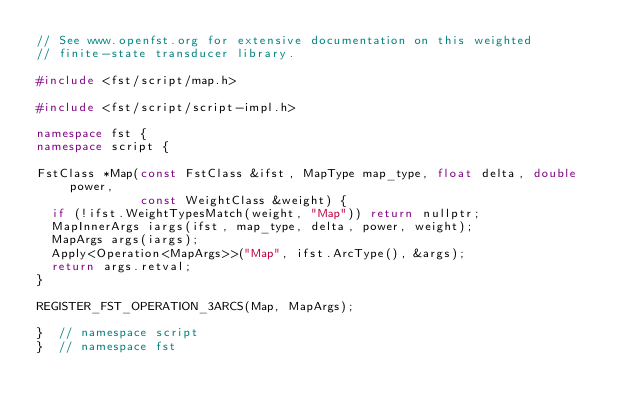<code> <loc_0><loc_0><loc_500><loc_500><_C++_>// See www.openfst.org for extensive documentation on this weighted
// finite-state transducer library.

#include <fst/script/map.h>

#include <fst/script/script-impl.h>

namespace fst {
namespace script {

FstClass *Map(const FstClass &ifst, MapType map_type, float delta, double power,
              const WeightClass &weight) {
  if (!ifst.WeightTypesMatch(weight, "Map")) return nullptr;
  MapInnerArgs iargs(ifst, map_type, delta, power, weight);
  MapArgs args(iargs);
  Apply<Operation<MapArgs>>("Map", ifst.ArcType(), &args);
  return args.retval;
}

REGISTER_FST_OPERATION_3ARCS(Map, MapArgs);

}  // namespace script
}  // namespace fst
</code> 